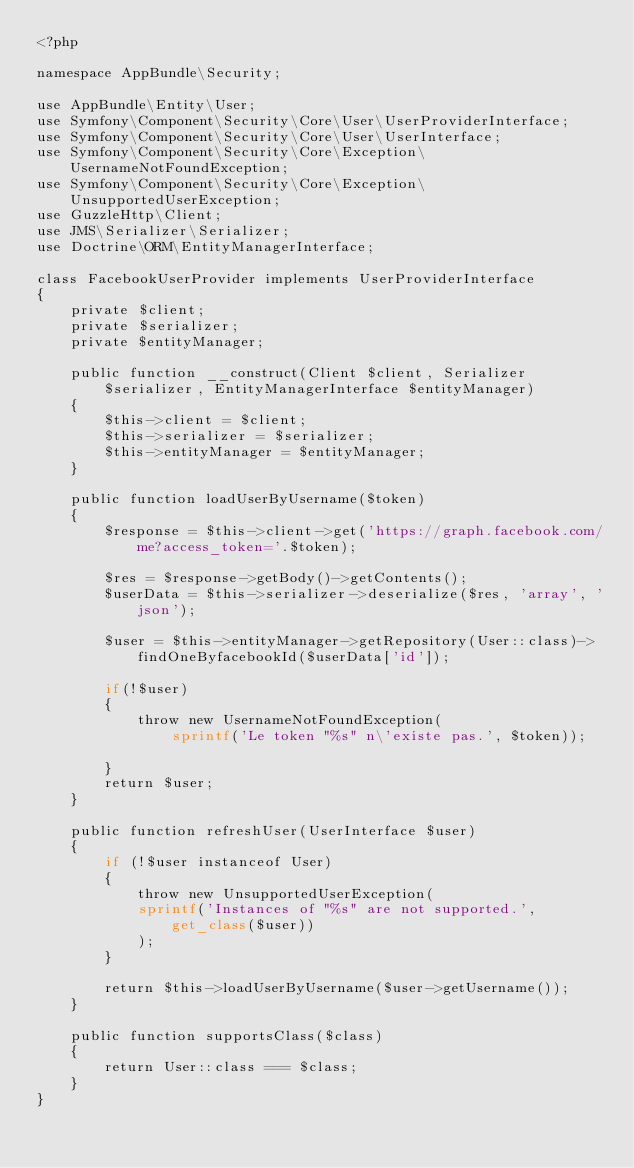<code> <loc_0><loc_0><loc_500><loc_500><_PHP_><?php

namespace AppBundle\Security;

use AppBundle\Entity\User;
use Symfony\Component\Security\Core\User\UserProviderInterface;
use Symfony\Component\Security\Core\User\UserInterface;
use Symfony\Component\Security\Core\Exception\UsernameNotFoundException;
use Symfony\Component\Security\Core\Exception\UnsupportedUserException;
use GuzzleHttp\Client;
use JMS\Serializer\Serializer;
use Doctrine\ORM\EntityManagerInterface;

class FacebookUserProvider implements UserProviderInterface
{
    private $client;
    private $serializer;
    private $entityManager;

    public function __construct(Client $client, Serializer $serializer, EntityManagerInterface $entityManager)
    {
        $this->client = $client;
        $this->serializer = $serializer;
        $this->entityManager = $entityManager;
    }

    public function loadUserByUsername($token)
    {
        $response = $this->client->get('https://graph.facebook.com/me?access_token='.$token);

        $res = $response->getBody()->getContents();
        $userData = $this->serializer->deserialize($res, 'array', 'json');

        $user = $this->entityManager->getRepository(User::class)->findOneByfacebookId($userData['id']);

        if(!$user)
        {
            throw new UsernameNotFoundException(
                sprintf('Le token "%s" n\'existe pas.', $token));

        }
        return $user;
    }

    public function refreshUser(UserInterface $user)
    {
        if (!$user instanceof User)
        {
            throw new UnsupportedUserException(
            sprintf('Instances of "%s" are not supported.', get_class($user))
            );
        }

        return $this->loadUserByUsername($user->getUsername());
    }

    public function supportsClass($class)
    {
        return User::class === $class;
    }
}</code> 